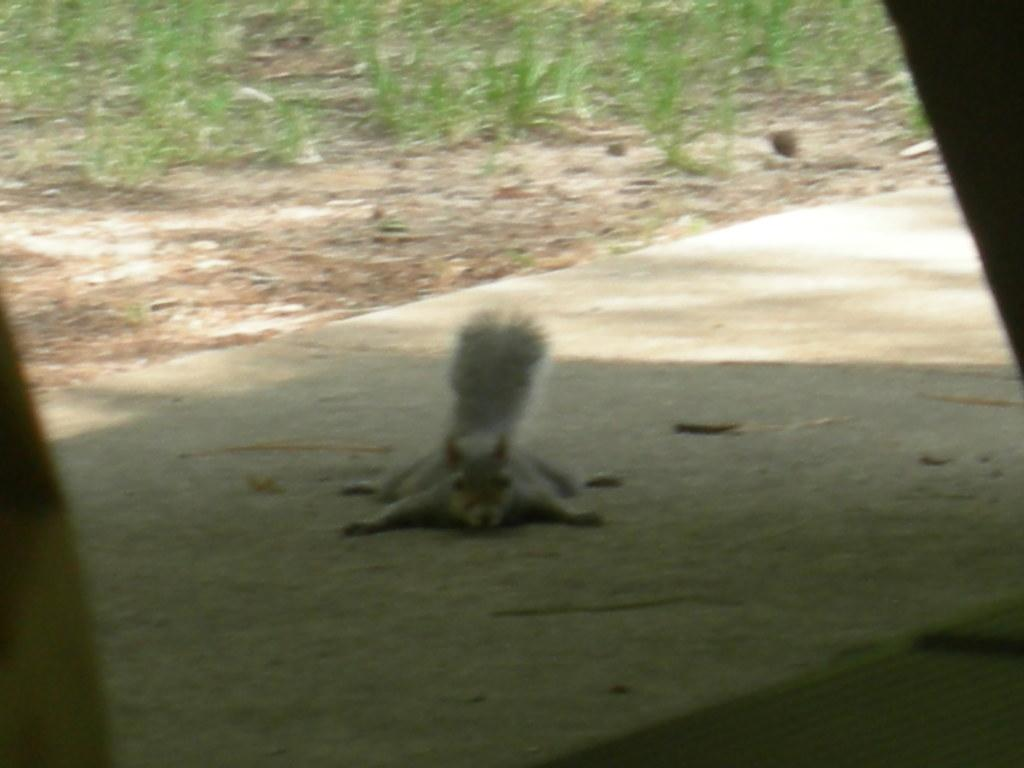What type of animal is in the image? There is a squirrel in the image. What color is the squirrel? The squirrel is ash in color. What position is the squirrel in? The squirrel is laying on the ground. What can be seen in the background of the image? There is ground and green grass visible in the background of the image. What type of jam is the squirrel eating in the image? There is no jam present in the image; it features a squirrel laying on the ground. What type of jeans is the squirrel wearing in the image? Squirrels do not wear jeans, and there is no clothing present in the image. 